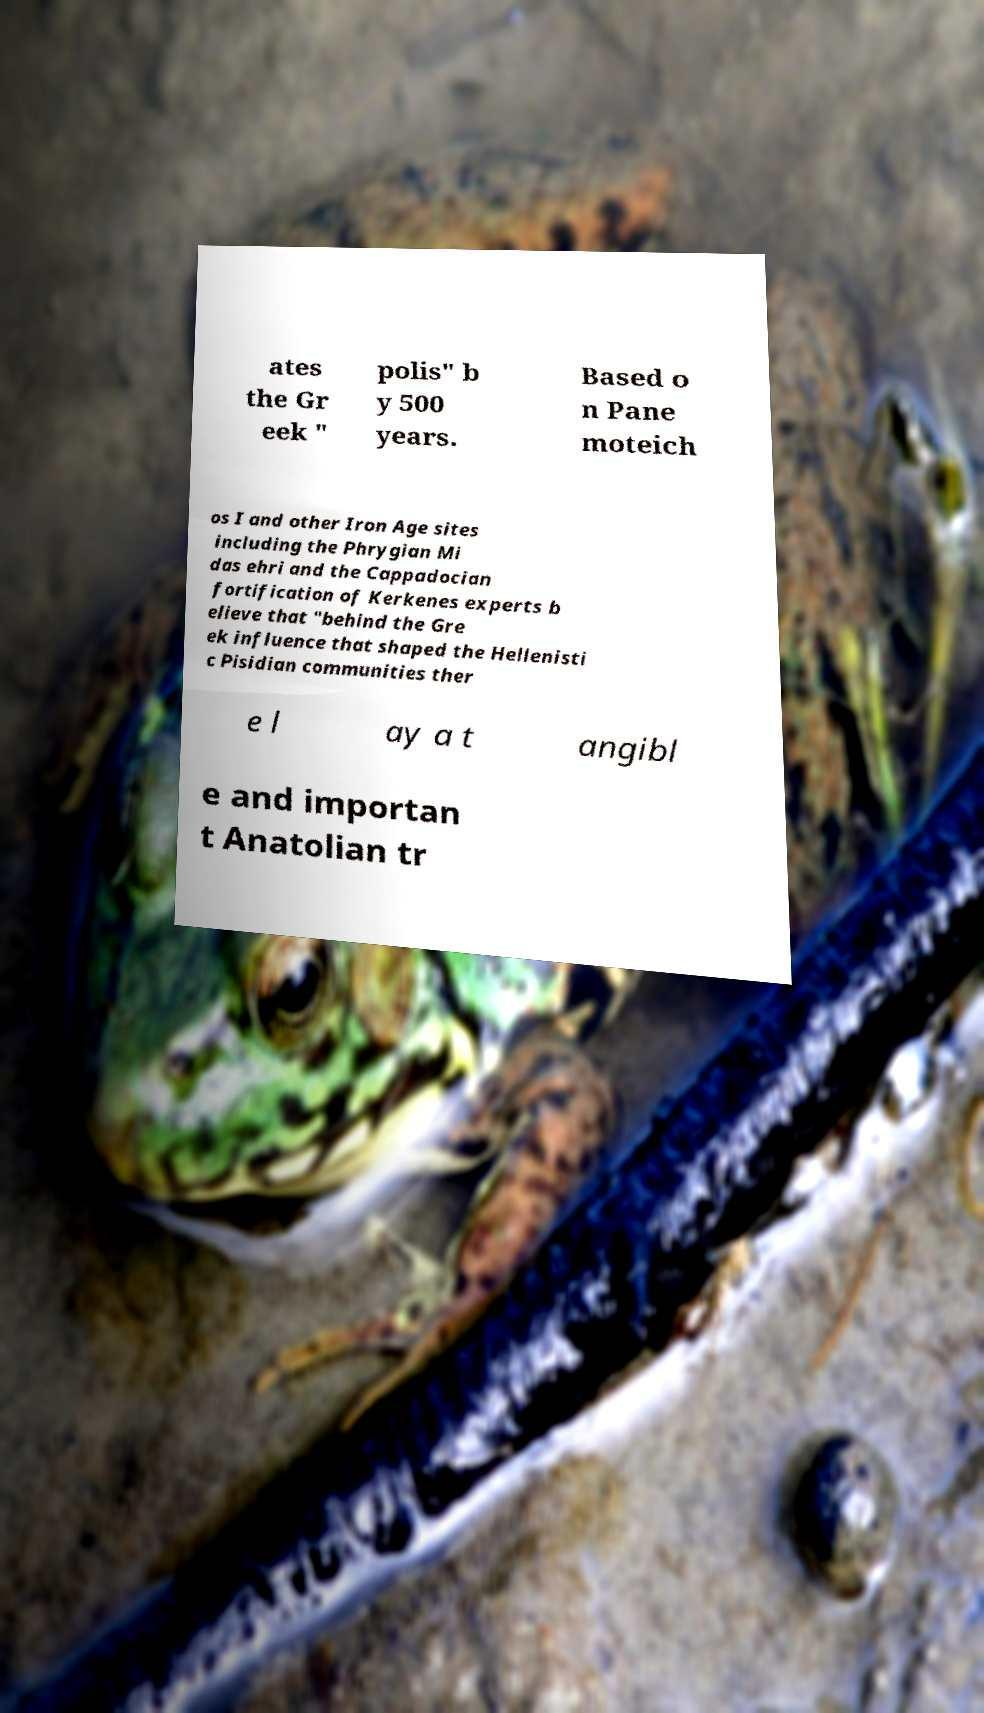Could you extract and type out the text from this image? ates the Gr eek " polis" b y 500 years. Based o n Pane moteich os I and other Iron Age sites including the Phrygian Mi das ehri and the Cappadocian fortification of Kerkenes experts b elieve that "behind the Gre ek influence that shaped the Hellenisti c Pisidian communities ther e l ay a t angibl e and importan t Anatolian tr 